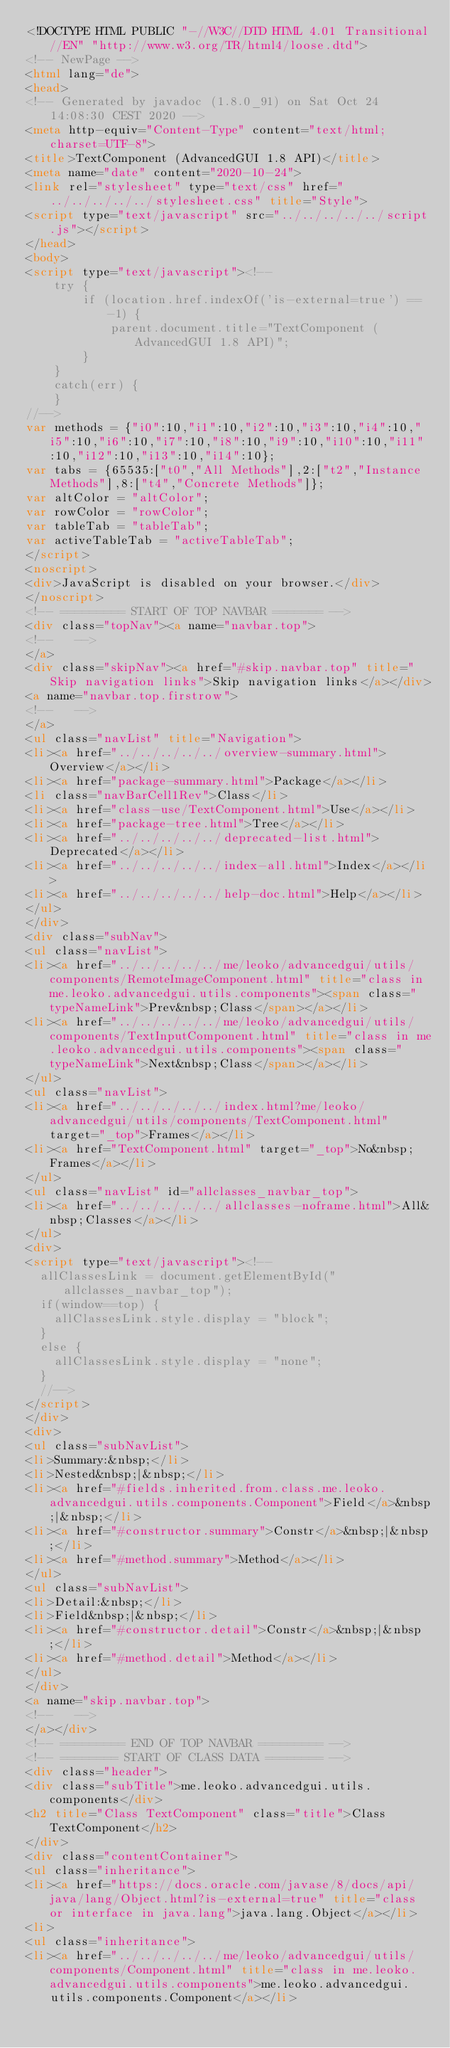<code> <loc_0><loc_0><loc_500><loc_500><_HTML_><!DOCTYPE HTML PUBLIC "-//W3C//DTD HTML 4.01 Transitional//EN" "http://www.w3.org/TR/html4/loose.dtd">
<!-- NewPage -->
<html lang="de">
<head>
<!-- Generated by javadoc (1.8.0_91) on Sat Oct 24 14:08:30 CEST 2020 -->
<meta http-equiv="Content-Type" content="text/html; charset=UTF-8">
<title>TextComponent (AdvancedGUI 1.8 API)</title>
<meta name="date" content="2020-10-24">
<link rel="stylesheet" type="text/css" href="../../../../../stylesheet.css" title="Style">
<script type="text/javascript" src="../../../../../script.js"></script>
</head>
<body>
<script type="text/javascript"><!--
    try {
        if (location.href.indexOf('is-external=true') == -1) {
            parent.document.title="TextComponent (AdvancedGUI 1.8 API)";
        }
    }
    catch(err) {
    }
//-->
var methods = {"i0":10,"i1":10,"i2":10,"i3":10,"i4":10,"i5":10,"i6":10,"i7":10,"i8":10,"i9":10,"i10":10,"i11":10,"i12":10,"i13":10,"i14":10};
var tabs = {65535:["t0","All Methods"],2:["t2","Instance Methods"],8:["t4","Concrete Methods"]};
var altColor = "altColor";
var rowColor = "rowColor";
var tableTab = "tableTab";
var activeTableTab = "activeTableTab";
</script>
<noscript>
<div>JavaScript is disabled on your browser.</div>
</noscript>
<!-- ========= START OF TOP NAVBAR ======= -->
<div class="topNav"><a name="navbar.top">
<!--   -->
</a>
<div class="skipNav"><a href="#skip.navbar.top" title="Skip navigation links">Skip navigation links</a></div>
<a name="navbar.top.firstrow">
<!--   -->
</a>
<ul class="navList" title="Navigation">
<li><a href="../../../../../overview-summary.html">Overview</a></li>
<li><a href="package-summary.html">Package</a></li>
<li class="navBarCell1Rev">Class</li>
<li><a href="class-use/TextComponent.html">Use</a></li>
<li><a href="package-tree.html">Tree</a></li>
<li><a href="../../../../../deprecated-list.html">Deprecated</a></li>
<li><a href="../../../../../index-all.html">Index</a></li>
<li><a href="../../../../../help-doc.html">Help</a></li>
</ul>
</div>
<div class="subNav">
<ul class="navList">
<li><a href="../../../../../me/leoko/advancedgui/utils/components/RemoteImageComponent.html" title="class in me.leoko.advancedgui.utils.components"><span class="typeNameLink">Prev&nbsp;Class</span></a></li>
<li><a href="../../../../../me/leoko/advancedgui/utils/components/TextInputComponent.html" title="class in me.leoko.advancedgui.utils.components"><span class="typeNameLink">Next&nbsp;Class</span></a></li>
</ul>
<ul class="navList">
<li><a href="../../../../../index.html?me/leoko/advancedgui/utils/components/TextComponent.html" target="_top">Frames</a></li>
<li><a href="TextComponent.html" target="_top">No&nbsp;Frames</a></li>
</ul>
<ul class="navList" id="allclasses_navbar_top">
<li><a href="../../../../../allclasses-noframe.html">All&nbsp;Classes</a></li>
</ul>
<div>
<script type="text/javascript"><!--
  allClassesLink = document.getElementById("allclasses_navbar_top");
  if(window==top) {
    allClassesLink.style.display = "block";
  }
  else {
    allClassesLink.style.display = "none";
  }
  //-->
</script>
</div>
<div>
<ul class="subNavList">
<li>Summary:&nbsp;</li>
<li>Nested&nbsp;|&nbsp;</li>
<li><a href="#fields.inherited.from.class.me.leoko.advancedgui.utils.components.Component">Field</a>&nbsp;|&nbsp;</li>
<li><a href="#constructor.summary">Constr</a>&nbsp;|&nbsp;</li>
<li><a href="#method.summary">Method</a></li>
</ul>
<ul class="subNavList">
<li>Detail:&nbsp;</li>
<li>Field&nbsp;|&nbsp;</li>
<li><a href="#constructor.detail">Constr</a>&nbsp;|&nbsp;</li>
<li><a href="#method.detail">Method</a></li>
</ul>
</div>
<a name="skip.navbar.top">
<!--   -->
</a></div>
<!-- ========= END OF TOP NAVBAR ========= -->
<!-- ======== START OF CLASS DATA ======== -->
<div class="header">
<div class="subTitle">me.leoko.advancedgui.utils.components</div>
<h2 title="Class TextComponent" class="title">Class TextComponent</h2>
</div>
<div class="contentContainer">
<ul class="inheritance">
<li><a href="https://docs.oracle.com/javase/8/docs/api/java/lang/Object.html?is-external=true" title="class or interface in java.lang">java.lang.Object</a></li>
<li>
<ul class="inheritance">
<li><a href="../../../../../me/leoko/advancedgui/utils/components/Component.html" title="class in me.leoko.advancedgui.utils.components">me.leoko.advancedgui.utils.components.Component</a></li></code> 